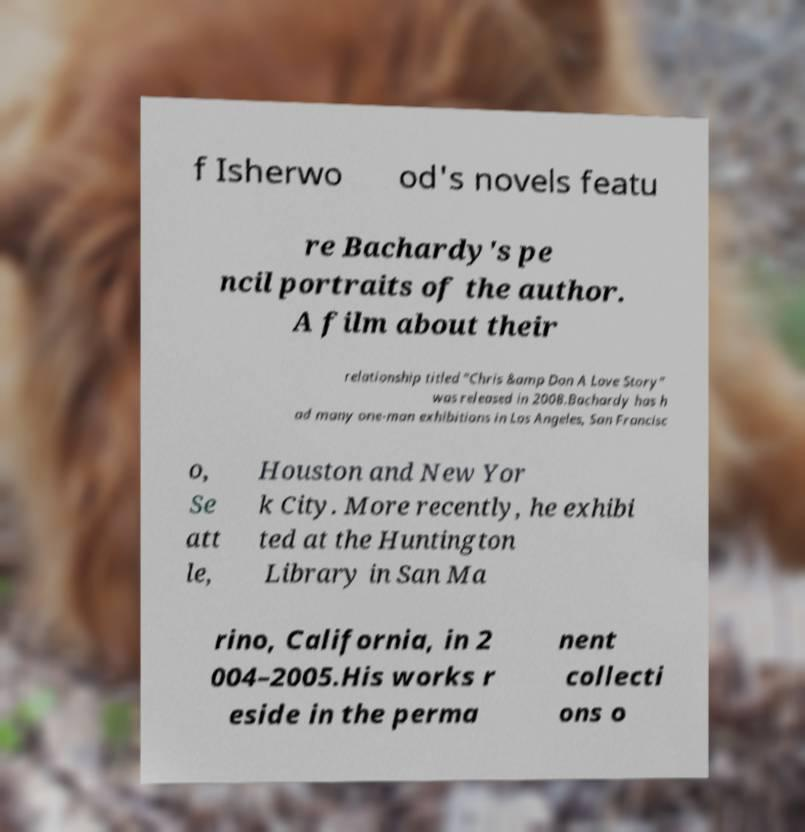Could you extract and type out the text from this image? f Isherwo od's novels featu re Bachardy's pe ncil portraits of the author. A film about their relationship titled "Chris &amp Don A Love Story" was released in 2008.Bachardy has h ad many one-man exhibitions in Los Angeles, San Francisc o, Se att le, Houston and New Yor k City. More recently, he exhibi ted at the Huntington Library in San Ma rino, California, in 2 004–2005.His works r eside in the perma nent collecti ons o 